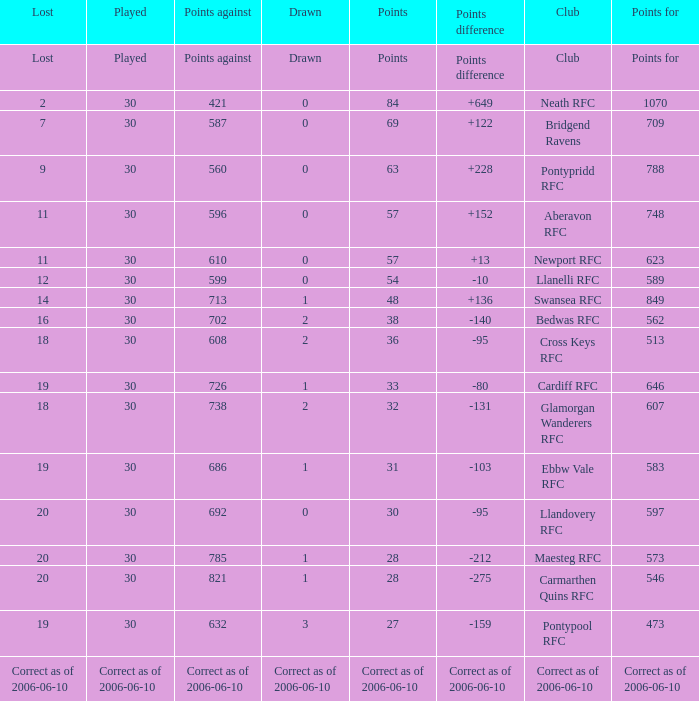What is Points For, when Points is "63"? 788.0. 